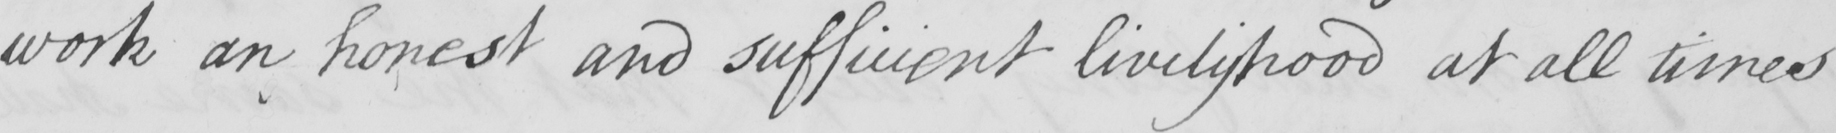What does this handwritten line say? work an honest and sufficient livelyhood at all times 